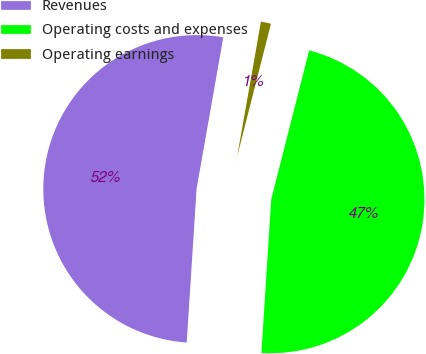<chart> <loc_0><loc_0><loc_500><loc_500><pie_chart><fcel>Revenues<fcel>Operating costs and expenses<fcel>Operating earnings<nl><fcel>51.76%<fcel>47.05%<fcel>1.19%<nl></chart> 